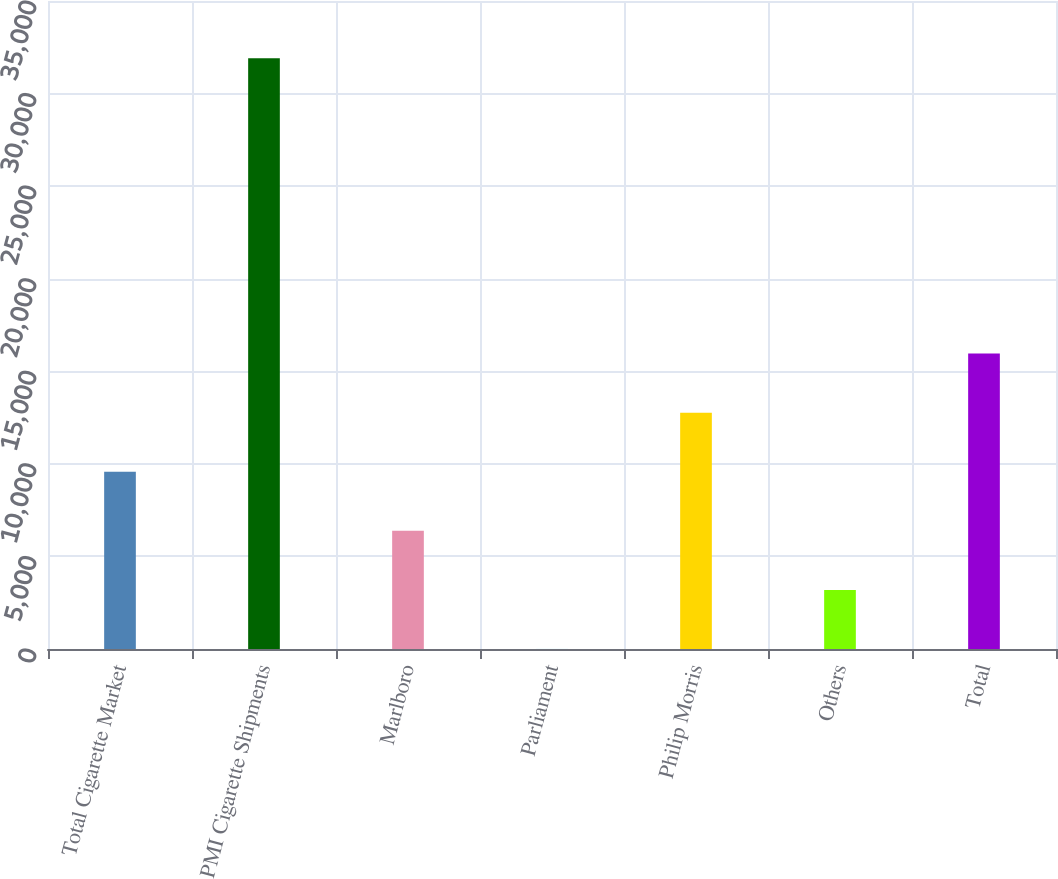Convert chart to OTSL. <chart><loc_0><loc_0><loc_500><loc_500><bar_chart><fcel>Total Cigarette Market<fcel>PMI Cigarette Shipments<fcel>Marlboro<fcel>Parliament<fcel>Philip Morris<fcel>Others<fcel>Total<nl><fcel>9574.47<fcel>31910<fcel>6383.68<fcel>2.1<fcel>12765.3<fcel>3192.89<fcel>15956<nl></chart> 